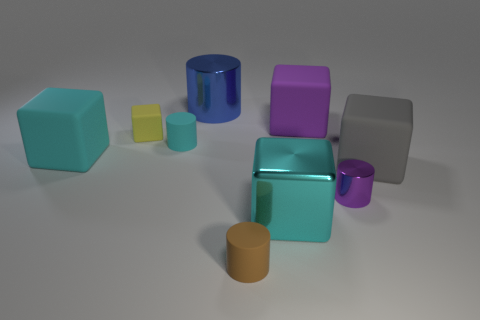The tiny thing right of the small brown rubber cylinder is what color?
Your answer should be compact. Purple. There is a cyan object on the left side of the tiny cyan cylinder; are there any blocks that are on the right side of it?
Your answer should be compact. Yes. Is the shape of the blue metal object the same as the tiny object that is right of the brown rubber thing?
Your response must be concise. Yes. How big is the cylinder that is in front of the yellow object and behind the gray cube?
Keep it short and to the point. Small. Are there any purple cylinders that have the same material as the blue object?
Ensure brevity in your answer.  Yes. There is a rubber cube that is the same color as the large metal block; what size is it?
Give a very brief answer. Large. The cyan object that is in front of the small object to the right of the cyan shiny block is made of what material?
Provide a short and direct response. Metal. What number of rubber objects have the same color as the tiny shiny cylinder?
Make the answer very short. 1. There is a purple object that is made of the same material as the tiny cube; what size is it?
Your answer should be very brief. Large. What is the shape of the matte object that is on the left side of the yellow matte object?
Offer a terse response. Cube. 